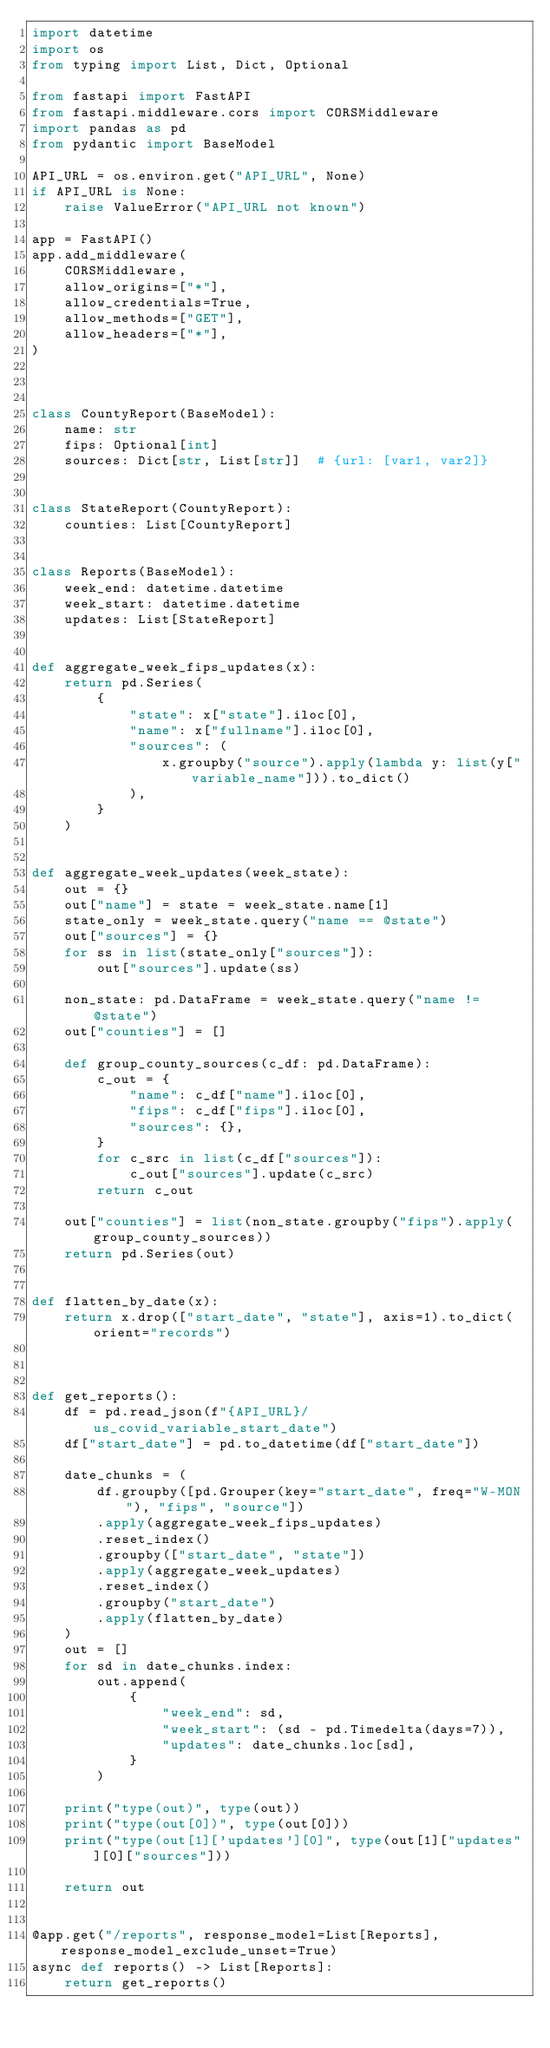Convert code to text. <code><loc_0><loc_0><loc_500><loc_500><_Python_>import datetime
import os
from typing import List, Dict, Optional

from fastapi import FastAPI
from fastapi.middleware.cors import CORSMiddleware
import pandas as pd
from pydantic import BaseModel

API_URL = os.environ.get("API_URL", None)
if API_URL is None:
    raise ValueError("API_URL not known")

app = FastAPI()
app.add_middleware(
    CORSMiddleware,
    allow_origins=["*"],
    allow_credentials=True,
    allow_methods=["GET"],
    allow_headers=["*"],
)



class CountyReport(BaseModel):
    name: str
    fips: Optional[int]
    sources: Dict[str, List[str]]  # {url: [var1, var2]}


class StateReport(CountyReport):
    counties: List[CountyReport]


class Reports(BaseModel):
    week_end: datetime.datetime
    week_start: datetime.datetime
    updates: List[StateReport]


def aggregate_week_fips_updates(x):
    return pd.Series(
        {
            "state": x["state"].iloc[0],
            "name": x["fullname"].iloc[0],
            "sources": (
                x.groupby("source").apply(lambda y: list(y["variable_name"])).to_dict()
            ),
        }
    )


def aggregate_week_updates(week_state):
    out = {}
    out["name"] = state = week_state.name[1]
    state_only = week_state.query("name == @state")
    out["sources"] = {}
    for ss in list(state_only["sources"]):
        out["sources"].update(ss)

    non_state: pd.DataFrame = week_state.query("name != @state")
    out["counties"] = []

    def group_county_sources(c_df: pd.DataFrame):
        c_out = {
            "name": c_df["name"].iloc[0],
            "fips": c_df["fips"].iloc[0],
            "sources": {},
        }
        for c_src in list(c_df["sources"]):
            c_out["sources"].update(c_src)
        return c_out

    out["counties"] = list(non_state.groupby("fips").apply(group_county_sources))
    return pd.Series(out)


def flatten_by_date(x):
    return x.drop(["start_date", "state"], axis=1).to_dict(orient="records")



def get_reports():
    df = pd.read_json(f"{API_URL}/us_covid_variable_start_date")
    df["start_date"] = pd.to_datetime(df["start_date"])

    date_chunks = (
        df.groupby([pd.Grouper(key="start_date", freq="W-MON"), "fips", "source"])
        .apply(aggregate_week_fips_updates)
        .reset_index()
        .groupby(["start_date", "state"])
        .apply(aggregate_week_updates)
        .reset_index()
        .groupby("start_date")
        .apply(flatten_by_date)
    )
    out = []
    for sd in date_chunks.index:
        out.append(
            {
                "week_end": sd,
                "week_start": (sd - pd.Timedelta(days=7)),
                "updates": date_chunks.loc[sd],
            }
        )

    print("type(out)", type(out))
    print("type(out[0])", type(out[0]))
    print("type(out[1]['updates'][0]", type(out[1]["updates"][0]["sources"]))

    return out


@app.get("/reports", response_model=List[Reports], response_model_exclude_unset=True)
async def reports() -> List[Reports]:
    return get_reports()
</code> 